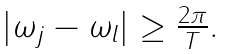Convert formula to latex. <formula><loc_0><loc_0><loc_500><loc_500>\begin{array} { c } | \omega _ { j } - \omega _ { l } | \geq \frac { 2 \pi } T . \end{array}</formula> 